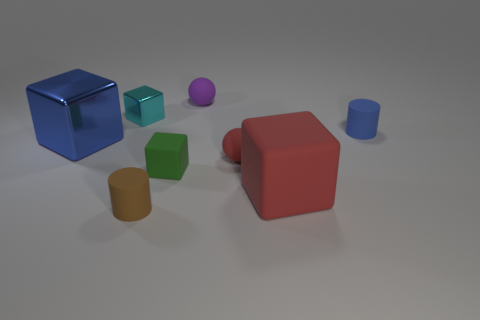Is there anything else that is made of the same material as the red block?
Provide a succinct answer. Yes. Do the tiny cylinder left of the tiny blue rubber object and the blue cube have the same material?
Keep it short and to the point. No. What is the material of the large red cube that is in front of the metal thing that is behind the small cylinder that is to the right of the small brown cylinder?
Make the answer very short. Rubber. What number of other things are there of the same shape as the tiny green object?
Offer a terse response. 3. What is the color of the tiny thing left of the tiny brown rubber cylinder?
Your answer should be compact. Cyan. There is a tiny rubber ball in front of the cube that is on the left side of the tiny metal thing; how many small green cubes are behind it?
Your response must be concise. 0. There is a matte ball to the right of the small purple rubber ball; how many spheres are in front of it?
Your answer should be very brief. 0. There is a brown cylinder; what number of small blue rubber cylinders are on the left side of it?
Your response must be concise. 0. What number of other objects are there of the same size as the brown cylinder?
Make the answer very short. 5. The red rubber thing that is the same shape as the small purple matte object is what size?
Keep it short and to the point. Small. 